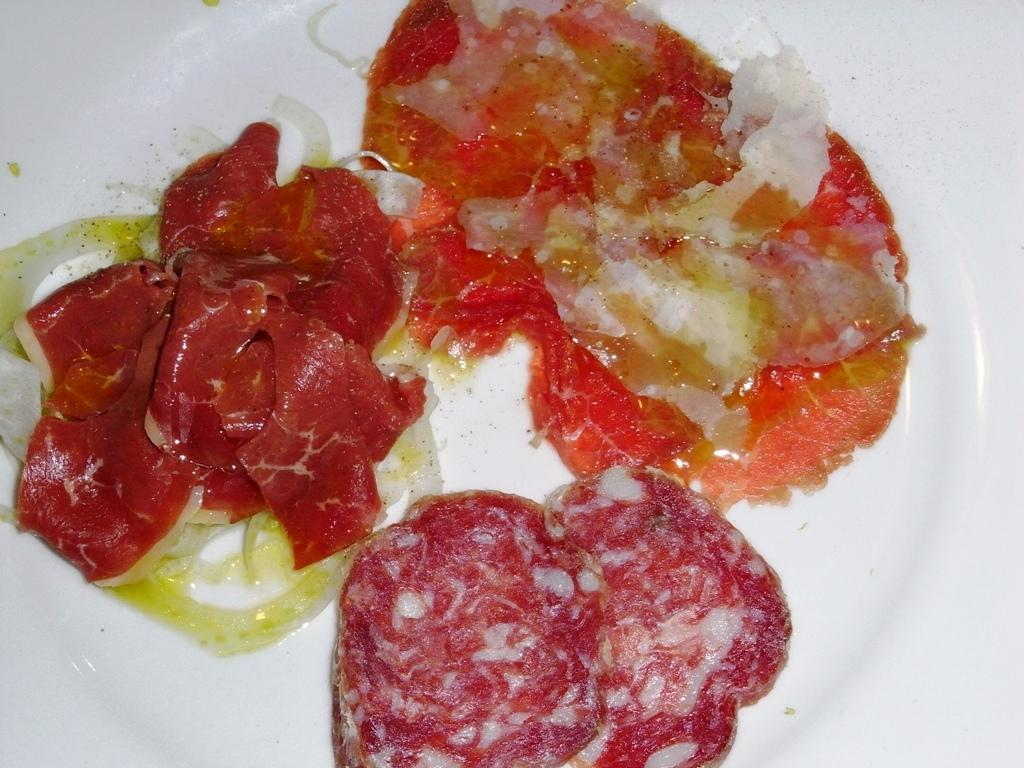What is present on the plate in the image? There are food items on the plate in the image. Can you describe the plate in more detail? Unfortunately, the facts provided do not give any additional details about the plate. What type of battle is depicted on the plate in the image? There is no battle depicted on the plate in the image; it only contains food items. 